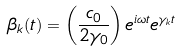Convert formula to latex. <formula><loc_0><loc_0><loc_500><loc_500>\beta _ { k } ( t ) = \left ( \frac { c _ { 0 } } { 2 \gamma _ { 0 } } \right ) e ^ { i \omega t } e ^ { \gamma _ { k } t }</formula> 